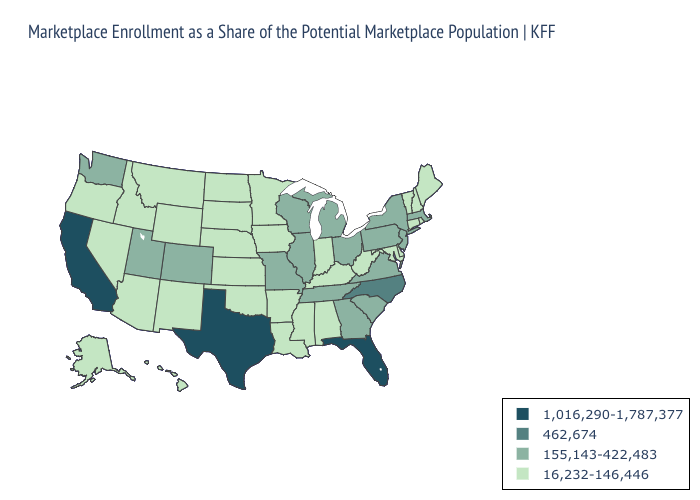What is the value of Missouri?
Write a very short answer. 155,143-422,483. Name the states that have a value in the range 16,232-146,446?
Concise answer only. Alabama, Alaska, Arizona, Arkansas, Connecticut, Delaware, Hawaii, Idaho, Indiana, Iowa, Kansas, Kentucky, Louisiana, Maine, Maryland, Minnesota, Mississippi, Montana, Nebraska, Nevada, New Hampshire, New Mexico, North Dakota, Oklahoma, Oregon, Rhode Island, South Dakota, Vermont, West Virginia, Wyoming. Name the states that have a value in the range 462,674?
Answer briefly. North Carolina. Does Missouri have a lower value than Louisiana?
Give a very brief answer. No. What is the value of Michigan?
Concise answer only. 155,143-422,483. Does New Mexico have the highest value in the West?
Write a very short answer. No. Which states have the lowest value in the USA?
Keep it brief. Alabama, Alaska, Arizona, Arkansas, Connecticut, Delaware, Hawaii, Idaho, Indiana, Iowa, Kansas, Kentucky, Louisiana, Maine, Maryland, Minnesota, Mississippi, Montana, Nebraska, Nevada, New Hampshire, New Mexico, North Dakota, Oklahoma, Oregon, Rhode Island, South Dakota, Vermont, West Virginia, Wyoming. What is the highest value in states that border Massachusetts?
Give a very brief answer. 155,143-422,483. Among the states that border Oregon , does Washington have the lowest value?
Keep it brief. No. Does the first symbol in the legend represent the smallest category?
Answer briefly. No. What is the lowest value in the MidWest?
Short answer required. 16,232-146,446. Name the states that have a value in the range 1,016,290-1,787,377?
Be succinct. California, Florida, Texas. Does the first symbol in the legend represent the smallest category?
Short answer required. No. Name the states that have a value in the range 155,143-422,483?
Be succinct. Colorado, Georgia, Illinois, Massachusetts, Michigan, Missouri, New Jersey, New York, Ohio, Pennsylvania, South Carolina, Tennessee, Utah, Virginia, Washington, Wisconsin. What is the value of Alaska?
Be succinct. 16,232-146,446. 